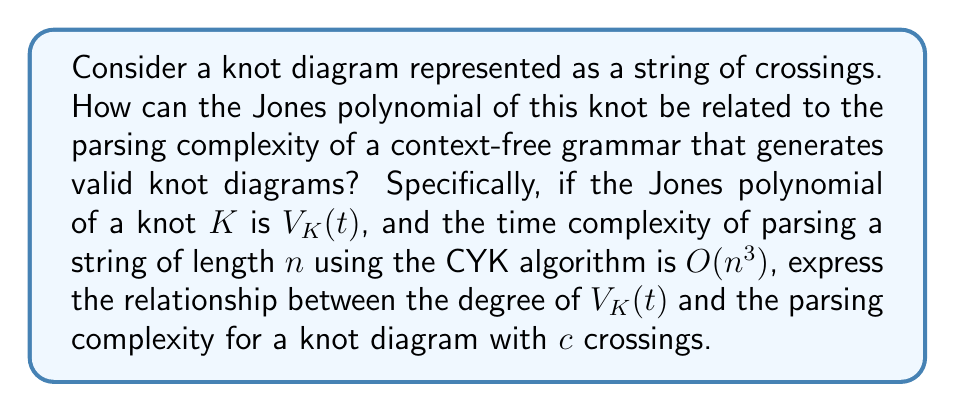What is the answer to this math problem? To solve this problem, let's break it down into steps:

1. The Jones polynomial $V_K(t)$ is a knot invariant that can be calculated from a knot diagram. The degree of $V_K(t)$ is related to the complexity of the knot.

2. For a knot with c crossings, the maximum degree of the Jones polynomial is typically bounded by $c-1$. This means:

   $\deg(V_K(t)) \leq c-1$

3. In a knot diagram represented as a string of crossings, the length of the string n is directly proportional to the number of crossings c. We can say:

   $n \propto c$ or $n = kc$ for some constant $k$

4. The CYK (Cocke-Younger-Kasami) algorithm for parsing context-free grammars has a time complexity of $O(n^3)$ for a string of length n.

5. Substituting $n = kc$ into the CYK complexity:

   $O(n^3) = O((kc)^3) = O(k^3c^3) = O(c^3)$

6. Now, we can relate the degree of the Jones polynomial to the parsing complexity:

   $\deg(V_K(t)) + 1 \leq c \approx O(\sqrt[3]{\text{parsing complexity}})$

This relationship shows that the degree of the Jones polynomial plus one is bounded by the cube root of the parsing complexity order.
Answer: $\deg(V_K(t)) + 1 \leq O(\sqrt[3]{\text{parsing complexity}})$ 